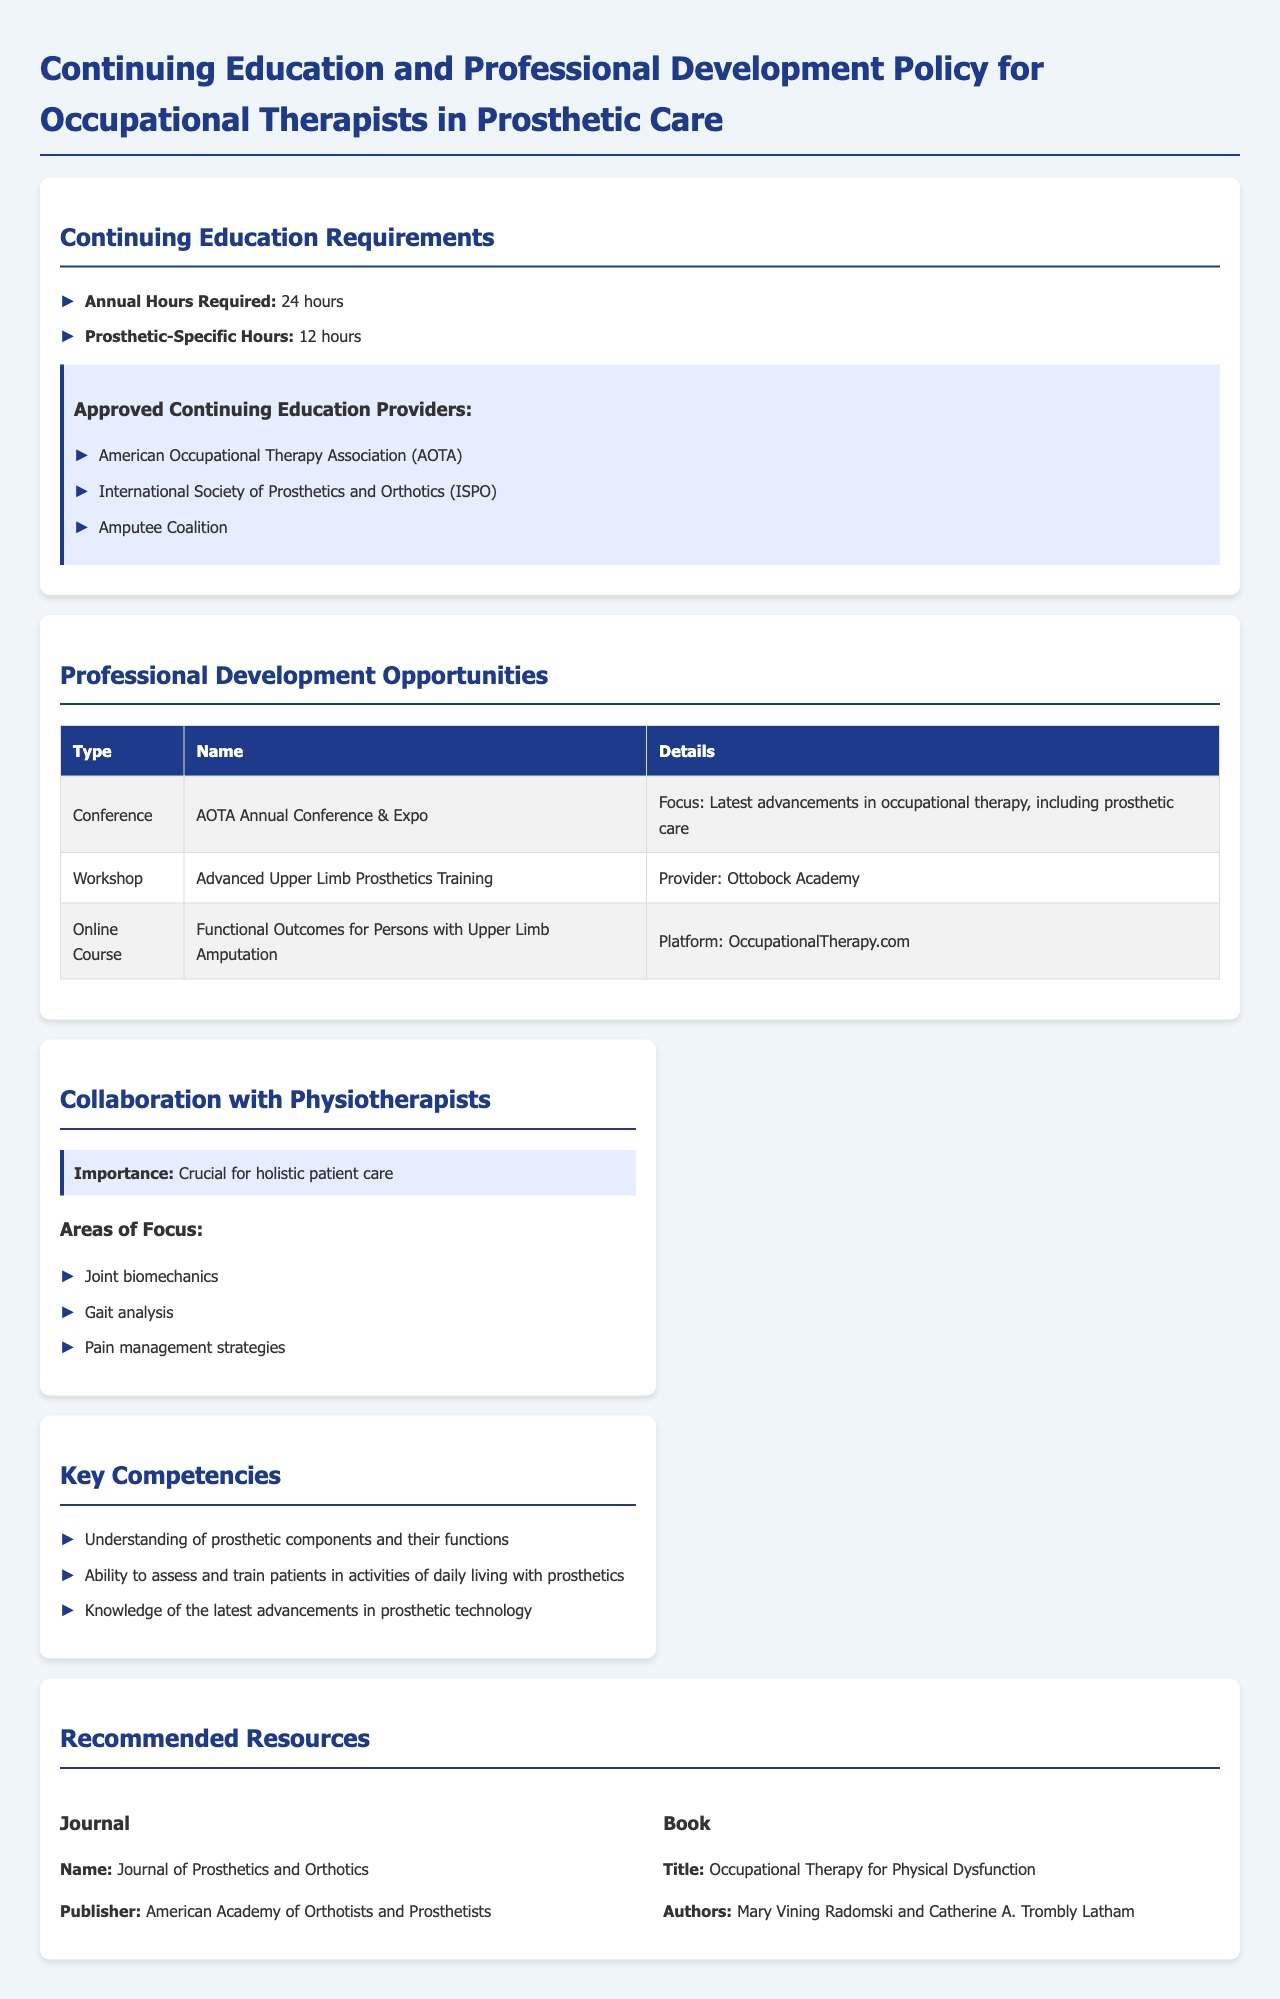what is the annual hours required for continuing education? The document states that occupational therapists are required to complete 24 hours of continuing education annually.
Answer: 24 hours how many hours of prosthetic-specific education are needed? The document specifies that 12 hours of the total continuing education must be prosthetic-specific.
Answer: 12 hours who provides approved continuing education for occupational therapists in prosthetic care? The document lists three approved providers: American Occupational Therapy Association, International Society of Prosthetics and Orthotics, and Amputee Coalition.
Answer: American Occupational Therapy Association, International Society of Prosthetics and Orthotics, Amputee Coalition what type of professional development opportunity is the AOTA Annual Conference & Expo? The document indicates that it is classified as a conference focusing on advancements in occupational therapy, including prosthetic care.
Answer: Conference name one recommended journal for occupational therapists in prosthetic care. The document mentions the Journal of Prosthetics and Orthotics as a recommended resource.
Answer: Journal of Prosthetics and Orthotics what are two key competencies for occupational therapists in this field? The document specifies understanding of prosthetic components and the ability to assess and train patients in activities of daily living with prosthetics as key competencies.
Answer: Understanding of prosthetic components and ability to assess and train patients how does collaboration with physiotherapists benefit patient care? The document emphasizes that collaboration is crucial for holistic patient care.
Answer: Holistic patient care which professional development opportunity focuses on upper limb prosthetics? The document refers to the "Advanced Upper Limb Prosthetics Training" as a workshop provided by Ottobock Academy.
Answer: Advanced Upper Limb Prosthetics Training what is one major area of focus in the collaboration with physiotherapists? The document lists joint biomechanics as a key area of focus for collaboration.
Answer: Joint biomechanics 